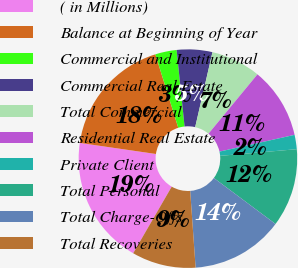Convert chart to OTSL. <chart><loc_0><loc_0><loc_500><loc_500><pie_chart><fcel>( in Millions)<fcel>Balance at Beginning of Year<fcel>Commercial and Institutional<fcel>Commercial Real Estate<fcel>Total Commercial<fcel>Residential Real Estate<fcel>Private Client<fcel>Total Personal<fcel>Total Charge-Offs<fcel>Total Recoveries<nl><fcel>18.95%<fcel>17.89%<fcel>3.16%<fcel>5.26%<fcel>7.37%<fcel>10.53%<fcel>2.11%<fcel>11.58%<fcel>13.68%<fcel>9.47%<nl></chart> 